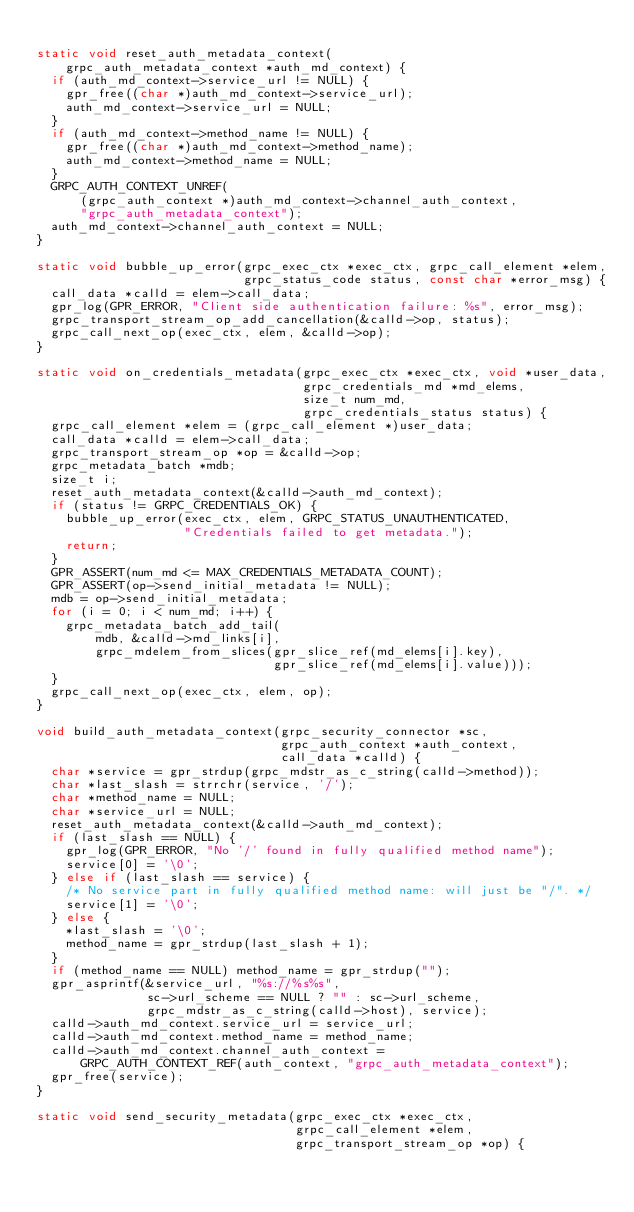Convert code to text. <code><loc_0><loc_0><loc_500><loc_500><_C_>
static void reset_auth_metadata_context(
    grpc_auth_metadata_context *auth_md_context) {
  if (auth_md_context->service_url != NULL) {
    gpr_free((char *)auth_md_context->service_url);
    auth_md_context->service_url = NULL;
  }
  if (auth_md_context->method_name != NULL) {
    gpr_free((char *)auth_md_context->method_name);
    auth_md_context->method_name = NULL;
  }
  GRPC_AUTH_CONTEXT_UNREF(
      (grpc_auth_context *)auth_md_context->channel_auth_context,
      "grpc_auth_metadata_context");
  auth_md_context->channel_auth_context = NULL;
}

static void bubble_up_error(grpc_exec_ctx *exec_ctx, grpc_call_element *elem,
                            grpc_status_code status, const char *error_msg) {
  call_data *calld = elem->call_data;
  gpr_log(GPR_ERROR, "Client side authentication failure: %s", error_msg);
  grpc_transport_stream_op_add_cancellation(&calld->op, status);
  grpc_call_next_op(exec_ctx, elem, &calld->op);
}

static void on_credentials_metadata(grpc_exec_ctx *exec_ctx, void *user_data,
                                    grpc_credentials_md *md_elems,
                                    size_t num_md,
                                    grpc_credentials_status status) {
  grpc_call_element *elem = (grpc_call_element *)user_data;
  call_data *calld = elem->call_data;
  grpc_transport_stream_op *op = &calld->op;
  grpc_metadata_batch *mdb;
  size_t i;
  reset_auth_metadata_context(&calld->auth_md_context);
  if (status != GRPC_CREDENTIALS_OK) {
    bubble_up_error(exec_ctx, elem, GRPC_STATUS_UNAUTHENTICATED,
                    "Credentials failed to get metadata.");
    return;
  }
  GPR_ASSERT(num_md <= MAX_CREDENTIALS_METADATA_COUNT);
  GPR_ASSERT(op->send_initial_metadata != NULL);
  mdb = op->send_initial_metadata;
  for (i = 0; i < num_md; i++) {
    grpc_metadata_batch_add_tail(
        mdb, &calld->md_links[i],
        grpc_mdelem_from_slices(gpr_slice_ref(md_elems[i].key),
                                gpr_slice_ref(md_elems[i].value)));
  }
  grpc_call_next_op(exec_ctx, elem, op);
}

void build_auth_metadata_context(grpc_security_connector *sc,
                                 grpc_auth_context *auth_context,
                                 call_data *calld) {
  char *service = gpr_strdup(grpc_mdstr_as_c_string(calld->method));
  char *last_slash = strrchr(service, '/');
  char *method_name = NULL;
  char *service_url = NULL;
  reset_auth_metadata_context(&calld->auth_md_context);
  if (last_slash == NULL) {
    gpr_log(GPR_ERROR, "No '/' found in fully qualified method name");
    service[0] = '\0';
  } else if (last_slash == service) {
    /* No service part in fully qualified method name: will just be "/". */
    service[1] = '\0';
  } else {
    *last_slash = '\0';
    method_name = gpr_strdup(last_slash + 1);
  }
  if (method_name == NULL) method_name = gpr_strdup("");
  gpr_asprintf(&service_url, "%s://%s%s",
               sc->url_scheme == NULL ? "" : sc->url_scheme,
               grpc_mdstr_as_c_string(calld->host), service);
  calld->auth_md_context.service_url = service_url;
  calld->auth_md_context.method_name = method_name;
  calld->auth_md_context.channel_auth_context =
      GRPC_AUTH_CONTEXT_REF(auth_context, "grpc_auth_metadata_context");
  gpr_free(service);
}

static void send_security_metadata(grpc_exec_ctx *exec_ctx,
                                   grpc_call_element *elem,
                                   grpc_transport_stream_op *op) {</code> 